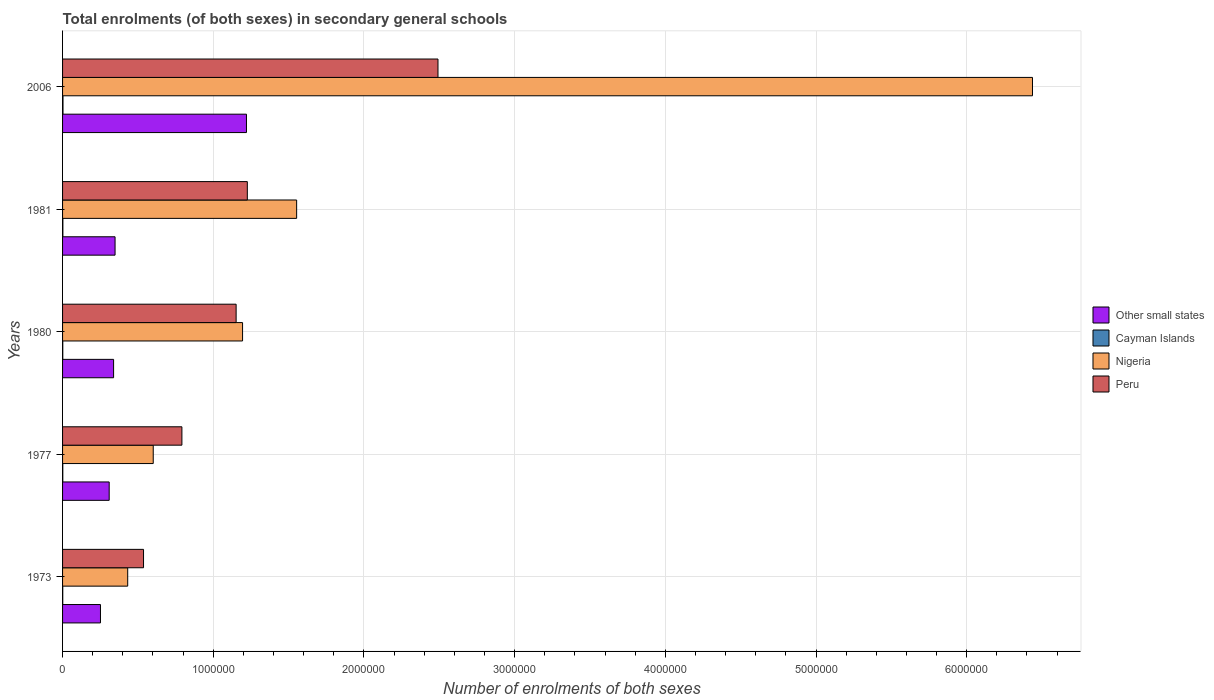How many different coloured bars are there?
Provide a succinct answer. 4. How many groups of bars are there?
Keep it short and to the point. 5. Are the number of bars per tick equal to the number of legend labels?
Your answer should be compact. Yes. Are the number of bars on each tick of the Y-axis equal?
Make the answer very short. Yes. What is the label of the 3rd group of bars from the top?
Offer a terse response. 1980. What is the number of enrolments in secondary schools in Nigeria in 2006?
Provide a short and direct response. 6.44e+06. Across all years, what is the maximum number of enrolments in secondary schools in Nigeria?
Offer a very short reply. 6.44e+06. Across all years, what is the minimum number of enrolments in secondary schools in Peru?
Your answer should be compact. 5.37e+05. In which year was the number of enrolments in secondary schools in Peru minimum?
Give a very brief answer. 1973. What is the total number of enrolments in secondary schools in Nigeria in the graph?
Provide a short and direct response. 1.02e+07. What is the difference between the number of enrolments in secondary schools in Peru in 1977 and that in 1980?
Your response must be concise. -3.60e+05. What is the difference between the number of enrolments in secondary schools in Cayman Islands in 1980 and the number of enrolments in secondary schools in Peru in 1977?
Offer a terse response. -7.90e+05. What is the average number of enrolments in secondary schools in Cayman Islands per year?
Offer a terse response. 1833. In the year 1973, what is the difference between the number of enrolments in secondary schools in Nigeria and number of enrolments in secondary schools in Other small states?
Give a very brief answer. 1.81e+05. What is the ratio of the number of enrolments in secondary schools in Cayman Islands in 1973 to that in 1980?
Your answer should be very brief. 0.82. Is the difference between the number of enrolments in secondary schools in Nigeria in 1977 and 1980 greater than the difference between the number of enrolments in secondary schools in Other small states in 1977 and 1980?
Provide a succinct answer. No. What is the difference between the highest and the second highest number of enrolments in secondary schools in Peru?
Offer a terse response. 1.27e+06. What is the difference between the highest and the lowest number of enrolments in secondary schools in Other small states?
Offer a terse response. 9.69e+05. Is the sum of the number of enrolments in secondary schools in Other small states in 1973 and 1977 greater than the maximum number of enrolments in secondary schools in Nigeria across all years?
Provide a succinct answer. No. What does the 4th bar from the top in 1973 represents?
Offer a very short reply. Other small states. What does the 3rd bar from the bottom in 2006 represents?
Offer a terse response. Nigeria. Is it the case that in every year, the sum of the number of enrolments in secondary schools in Nigeria and number of enrolments in secondary schools in Other small states is greater than the number of enrolments in secondary schools in Cayman Islands?
Ensure brevity in your answer.  Yes. Are all the bars in the graph horizontal?
Your answer should be very brief. Yes. How are the legend labels stacked?
Give a very brief answer. Vertical. What is the title of the graph?
Offer a very short reply. Total enrolments (of both sexes) in secondary general schools. Does "Tuvalu" appear as one of the legend labels in the graph?
Your response must be concise. No. What is the label or title of the X-axis?
Offer a terse response. Number of enrolments of both sexes. What is the label or title of the Y-axis?
Your response must be concise. Years. What is the Number of enrolments of both sexes of Other small states in 1973?
Your answer should be very brief. 2.52e+05. What is the Number of enrolments of both sexes of Cayman Islands in 1973?
Offer a very short reply. 1187. What is the Number of enrolments of both sexes of Nigeria in 1973?
Ensure brevity in your answer.  4.32e+05. What is the Number of enrolments of both sexes in Peru in 1973?
Provide a succinct answer. 5.37e+05. What is the Number of enrolments of both sexes in Other small states in 1977?
Your answer should be compact. 3.09e+05. What is the Number of enrolments of both sexes of Cayman Islands in 1977?
Your response must be concise. 1558. What is the Number of enrolments of both sexes of Nigeria in 1977?
Ensure brevity in your answer.  6.02e+05. What is the Number of enrolments of both sexes of Peru in 1977?
Your response must be concise. 7.92e+05. What is the Number of enrolments of both sexes in Other small states in 1980?
Provide a succinct answer. 3.39e+05. What is the Number of enrolments of both sexes in Cayman Islands in 1980?
Ensure brevity in your answer.  1446. What is the Number of enrolments of both sexes of Nigeria in 1980?
Make the answer very short. 1.19e+06. What is the Number of enrolments of both sexes in Peru in 1980?
Give a very brief answer. 1.15e+06. What is the Number of enrolments of both sexes of Other small states in 1981?
Your answer should be very brief. 3.48e+05. What is the Number of enrolments of both sexes in Cayman Islands in 1981?
Provide a short and direct response. 2075. What is the Number of enrolments of both sexes of Nigeria in 1981?
Offer a terse response. 1.55e+06. What is the Number of enrolments of both sexes of Peru in 1981?
Your response must be concise. 1.23e+06. What is the Number of enrolments of both sexes of Other small states in 2006?
Your response must be concise. 1.22e+06. What is the Number of enrolments of both sexes of Cayman Islands in 2006?
Provide a short and direct response. 2899. What is the Number of enrolments of both sexes of Nigeria in 2006?
Provide a short and direct response. 6.44e+06. What is the Number of enrolments of both sexes in Peru in 2006?
Ensure brevity in your answer.  2.49e+06. Across all years, what is the maximum Number of enrolments of both sexes of Other small states?
Your answer should be very brief. 1.22e+06. Across all years, what is the maximum Number of enrolments of both sexes of Cayman Islands?
Your response must be concise. 2899. Across all years, what is the maximum Number of enrolments of both sexes of Nigeria?
Provide a short and direct response. 6.44e+06. Across all years, what is the maximum Number of enrolments of both sexes of Peru?
Provide a short and direct response. 2.49e+06. Across all years, what is the minimum Number of enrolments of both sexes in Other small states?
Make the answer very short. 2.52e+05. Across all years, what is the minimum Number of enrolments of both sexes in Cayman Islands?
Offer a very short reply. 1187. Across all years, what is the minimum Number of enrolments of both sexes of Nigeria?
Offer a terse response. 4.32e+05. Across all years, what is the minimum Number of enrolments of both sexes of Peru?
Give a very brief answer. 5.37e+05. What is the total Number of enrolments of both sexes in Other small states in the graph?
Offer a very short reply. 2.47e+06. What is the total Number of enrolments of both sexes of Cayman Islands in the graph?
Make the answer very short. 9165. What is the total Number of enrolments of both sexes in Nigeria in the graph?
Your response must be concise. 1.02e+07. What is the total Number of enrolments of both sexes of Peru in the graph?
Give a very brief answer. 6.20e+06. What is the difference between the Number of enrolments of both sexes of Other small states in 1973 and that in 1977?
Provide a succinct answer. -5.79e+04. What is the difference between the Number of enrolments of both sexes in Cayman Islands in 1973 and that in 1977?
Make the answer very short. -371. What is the difference between the Number of enrolments of both sexes of Nigeria in 1973 and that in 1977?
Give a very brief answer. -1.69e+05. What is the difference between the Number of enrolments of both sexes of Peru in 1973 and that in 1977?
Make the answer very short. -2.55e+05. What is the difference between the Number of enrolments of both sexes of Other small states in 1973 and that in 1980?
Offer a terse response. -8.71e+04. What is the difference between the Number of enrolments of both sexes in Cayman Islands in 1973 and that in 1980?
Ensure brevity in your answer.  -259. What is the difference between the Number of enrolments of both sexes in Nigeria in 1973 and that in 1980?
Give a very brief answer. -7.62e+05. What is the difference between the Number of enrolments of both sexes of Peru in 1973 and that in 1980?
Provide a short and direct response. -6.14e+05. What is the difference between the Number of enrolments of both sexes in Other small states in 1973 and that in 1981?
Give a very brief answer. -9.68e+04. What is the difference between the Number of enrolments of both sexes in Cayman Islands in 1973 and that in 1981?
Your answer should be compact. -888. What is the difference between the Number of enrolments of both sexes of Nigeria in 1973 and that in 1981?
Your response must be concise. -1.12e+06. What is the difference between the Number of enrolments of both sexes in Peru in 1973 and that in 1981?
Offer a very short reply. -6.89e+05. What is the difference between the Number of enrolments of both sexes of Other small states in 1973 and that in 2006?
Your response must be concise. -9.69e+05. What is the difference between the Number of enrolments of both sexes of Cayman Islands in 1973 and that in 2006?
Provide a short and direct response. -1712. What is the difference between the Number of enrolments of both sexes of Nigeria in 1973 and that in 2006?
Provide a short and direct response. -6.00e+06. What is the difference between the Number of enrolments of both sexes of Peru in 1973 and that in 2006?
Make the answer very short. -1.95e+06. What is the difference between the Number of enrolments of both sexes of Other small states in 1977 and that in 1980?
Your answer should be very brief. -2.92e+04. What is the difference between the Number of enrolments of both sexes in Cayman Islands in 1977 and that in 1980?
Make the answer very short. 112. What is the difference between the Number of enrolments of both sexes in Nigeria in 1977 and that in 1980?
Keep it short and to the point. -5.93e+05. What is the difference between the Number of enrolments of both sexes of Peru in 1977 and that in 1980?
Ensure brevity in your answer.  -3.60e+05. What is the difference between the Number of enrolments of both sexes of Other small states in 1977 and that in 1981?
Provide a short and direct response. -3.89e+04. What is the difference between the Number of enrolments of both sexes in Cayman Islands in 1977 and that in 1981?
Offer a very short reply. -517. What is the difference between the Number of enrolments of both sexes of Nigeria in 1977 and that in 1981?
Offer a very short reply. -9.52e+05. What is the difference between the Number of enrolments of both sexes of Peru in 1977 and that in 1981?
Provide a short and direct response. -4.34e+05. What is the difference between the Number of enrolments of both sexes in Other small states in 1977 and that in 2006?
Your answer should be compact. -9.11e+05. What is the difference between the Number of enrolments of both sexes of Cayman Islands in 1977 and that in 2006?
Your answer should be very brief. -1341. What is the difference between the Number of enrolments of both sexes of Nigeria in 1977 and that in 2006?
Keep it short and to the point. -5.83e+06. What is the difference between the Number of enrolments of both sexes of Peru in 1977 and that in 2006?
Keep it short and to the point. -1.70e+06. What is the difference between the Number of enrolments of both sexes of Other small states in 1980 and that in 1981?
Your answer should be compact. -9750.81. What is the difference between the Number of enrolments of both sexes in Cayman Islands in 1980 and that in 1981?
Your answer should be compact. -629. What is the difference between the Number of enrolments of both sexes of Nigeria in 1980 and that in 1981?
Make the answer very short. -3.59e+05. What is the difference between the Number of enrolments of both sexes in Peru in 1980 and that in 1981?
Your answer should be compact. -7.44e+04. What is the difference between the Number of enrolments of both sexes in Other small states in 1980 and that in 2006?
Your answer should be very brief. -8.82e+05. What is the difference between the Number of enrolments of both sexes of Cayman Islands in 1980 and that in 2006?
Offer a very short reply. -1453. What is the difference between the Number of enrolments of both sexes of Nigeria in 1980 and that in 2006?
Offer a very short reply. -5.24e+06. What is the difference between the Number of enrolments of both sexes in Peru in 1980 and that in 2006?
Provide a short and direct response. -1.34e+06. What is the difference between the Number of enrolments of both sexes in Other small states in 1981 and that in 2006?
Give a very brief answer. -8.72e+05. What is the difference between the Number of enrolments of both sexes in Cayman Islands in 1981 and that in 2006?
Your response must be concise. -824. What is the difference between the Number of enrolments of both sexes in Nigeria in 1981 and that in 2006?
Your response must be concise. -4.88e+06. What is the difference between the Number of enrolments of both sexes of Peru in 1981 and that in 2006?
Your answer should be compact. -1.27e+06. What is the difference between the Number of enrolments of both sexes in Other small states in 1973 and the Number of enrolments of both sexes in Cayman Islands in 1977?
Offer a terse response. 2.50e+05. What is the difference between the Number of enrolments of both sexes in Other small states in 1973 and the Number of enrolments of both sexes in Nigeria in 1977?
Offer a terse response. -3.50e+05. What is the difference between the Number of enrolments of both sexes in Other small states in 1973 and the Number of enrolments of both sexes in Peru in 1977?
Provide a short and direct response. -5.40e+05. What is the difference between the Number of enrolments of both sexes in Cayman Islands in 1973 and the Number of enrolments of both sexes in Nigeria in 1977?
Your response must be concise. -6.00e+05. What is the difference between the Number of enrolments of both sexes of Cayman Islands in 1973 and the Number of enrolments of both sexes of Peru in 1977?
Provide a succinct answer. -7.91e+05. What is the difference between the Number of enrolments of both sexes of Nigeria in 1973 and the Number of enrolments of both sexes of Peru in 1977?
Give a very brief answer. -3.60e+05. What is the difference between the Number of enrolments of both sexes of Other small states in 1973 and the Number of enrolments of both sexes of Cayman Islands in 1980?
Ensure brevity in your answer.  2.50e+05. What is the difference between the Number of enrolments of both sexes in Other small states in 1973 and the Number of enrolments of both sexes in Nigeria in 1980?
Provide a short and direct response. -9.43e+05. What is the difference between the Number of enrolments of both sexes of Other small states in 1973 and the Number of enrolments of both sexes of Peru in 1980?
Give a very brief answer. -9.00e+05. What is the difference between the Number of enrolments of both sexes in Cayman Islands in 1973 and the Number of enrolments of both sexes in Nigeria in 1980?
Make the answer very short. -1.19e+06. What is the difference between the Number of enrolments of both sexes of Cayman Islands in 1973 and the Number of enrolments of both sexes of Peru in 1980?
Offer a very short reply. -1.15e+06. What is the difference between the Number of enrolments of both sexes in Nigeria in 1973 and the Number of enrolments of both sexes in Peru in 1980?
Your answer should be very brief. -7.19e+05. What is the difference between the Number of enrolments of both sexes in Other small states in 1973 and the Number of enrolments of both sexes in Cayman Islands in 1981?
Your answer should be very brief. 2.49e+05. What is the difference between the Number of enrolments of both sexes in Other small states in 1973 and the Number of enrolments of both sexes in Nigeria in 1981?
Provide a succinct answer. -1.30e+06. What is the difference between the Number of enrolments of both sexes of Other small states in 1973 and the Number of enrolments of both sexes of Peru in 1981?
Give a very brief answer. -9.75e+05. What is the difference between the Number of enrolments of both sexes of Cayman Islands in 1973 and the Number of enrolments of both sexes of Nigeria in 1981?
Your response must be concise. -1.55e+06. What is the difference between the Number of enrolments of both sexes of Cayman Islands in 1973 and the Number of enrolments of both sexes of Peru in 1981?
Provide a short and direct response. -1.22e+06. What is the difference between the Number of enrolments of both sexes of Nigeria in 1973 and the Number of enrolments of both sexes of Peru in 1981?
Provide a short and direct response. -7.94e+05. What is the difference between the Number of enrolments of both sexes in Other small states in 1973 and the Number of enrolments of both sexes in Cayman Islands in 2006?
Provide a succinct answer. 2.49e+05. What is the difference between the Number of enrolments of both sexes of Other small states in 1973 and the Number of enrolments of both sexes of Nigeria in 2006?
Ensure brevity in your answer.  -6.18e+06. What is the difference between the Number of enrolments of both sexes of Other small states in 1973 and the Number of enrolments of both sexes of Peru in 2006?
Keep it short and to the point. -2.24e+06. What is the difference between the Number of enrolments of both sexes in Cayman Islands in 1973 and the Number of enrolments of both sexes in Nigeria in 2006?
Your answer should be compact. -6.44e+06. What is the difference between the Number of enrolments of both sexes of Cayman Islands in 1973 and the Number of enrolments of both sexes of Peru in 2006?
Provide a short and direct response. -2.49e+06. What is the difference between the Number of enrolments of both sexes of Nigeria in 1973 and the Number of enrolments of both sexes of Peru in 2006?
Give a very brief answer. -2.06e+06. What is the difference between the Number of enrolments of both sexes of Other small states in 1977 and the Number of enrolments of both sexes of Cayman Islands in 1980?
Your answer should be very brief. 3.08e+05. What is the difference between the Number of enrolments of both sexes of Other small states in 1977 and the Number of enrolments of both sexes of Nigeria in 1980?
Provide a succinct answer. -8.85e+05. What is the difference between the Number of enrolments of both sexes in Other small states in 1977 and the Number of enrolments of both sexes in Peru in 1980?
Your answer should be compact. -8.42e+05. What is the difference between the Number of enrolments of both sexes of Cayman Islands in 1977 and the Number of enrolments of both sexes of Nigeria in 1980?
Offer a terse response. -1.19e+06. What is the difference between the Number of enrolments of both sexes of Cayman Islands in 1977 and the Number of enrolments of both sexes of Peru in 1980?
Your response must be concise. -1.15e+06. What is the difference between the Number of enrolments of both sexes in Nigeria in 1977 and the Number of enrolments of both sexes in Peru in 1980?
Your answer should be compact. -5.50e+05. What is the difference between the Number of enrolments of both sexes in Other small states in 1977 and the Number of enrolments of both sexes in Cayman Islands in 1981?
Ensure brevity in your answer.  3.07e+05. What is the difference between the Number of enrolments of both sexes in Other small states in 1977 and the Number of enrolments of both sexes in Nigeria in 1981?
Ensure brevity in your answer.  -1.24e+06. What is the difference between the Number of enrolments of both sexes in Other small states in 1977 and the Number of enrolments of both sexes in Peru in 1981?
Your answer should be compact. -9.17e+05. What is the difference between the Number of enrolments of both sexes in Cayman Islands in 1977 and the Number of enrolments of both sexes in Nigeria in 1981?
Keep it short and to the point. -1.55e+06. What is the difference between the Number of enrolments of both sexes of Cayman Islands in 1977 and the Number of enrolments of both sexes of Peru in 1981?
Make the answer very short. -1.22e+06. What is the difference between the Number of enrolments of both sexes in Nigeria in 1977 and the Number of enrolments of both sexes in Peru in 1981?
Your response must be concise. -6.24e+05. What is the difference between the Number of enrolments of both sexes in Other small states in 1977 and the Number of enrolments of both sexes in Cayman Islands in 2006?
Keep it short and to the point. 3.07e+05. What is the difference between the Number of enrolments of both sexes in Other small states in 1977 and the Number of enrolments of both sexes in Nigeria in 2006?
Offer a very short reply. -6.13e+06. What is the difference between the Number of enrolments of both sexes of Other small states in 1977 and the Number of enrolments of both sexes of Peru in 2006?
Give a very brief answer. -2.18e+06. What is the difference between the Number of enrolments of both sexes in Cayman Islands in 1977 and the Number of enrolments of both sexes in Nigeria in 2006?
Offer a terse response. -6.43e+06. What is the difference between the Number of enrolments of both sexes of Cayman Islands in 1977 and the Number of enrolments of both sexes of Peru in 2006?
Provide a succinct answer. -2.49e+06. What is the difference between the Number of enrolments of both sexes in Nigeria in 1977 and the Number of enrolments of both sexes in Peru in 2006?
Give a very brief answer. -1.89e+06. What is the difference between the Number of enrolments of both sexes of Other small states in 1980 and the Number of enrolments of both sexes of Cayman Islands in 1981?
Your response must be concise. 3.37e+05. What is the difference between the Number of enrolments of both sexes of Other small states in 1980 and the Number of enrolments of both sexes of Nigeria in 1981?
Your response must be concise. -1.21e+06. What is the difference between the Number of enrolments of both sexes in Other small states in 1980 and the Number of enrolments of both sexes in Peru in 1981?
Provide a short and direct response. -8.88e+05. What is the difference between the Number of enrolments of both sexes of Cayman Islands in 1980 and the Number of enrolments of both sexes of Nigeria in 1981?
Offer a very short reply. -1.55e+06. What is the difference between the Number of enrolments of both sexes in Cayman Islands in 1980 and the Number of enrolments of both sexes in Peru in 1981?
Your answer should be very brief. -1.22e+06. What is the difference between the Number of enrolments of both sexes of Nigeria in 1980 and the Number of enrolments of both sexes of Peru in 1981?
Make the answer very short. -3.17e+04. What is the difference between the Number of enrolments of both sexes in Other small states in 1980 and the Number of enrolments of both sexes in Cayman Islands in 2006?
Provide a succinct answer. 3.36e+05. What is the difference between the Number of enrolments of both sexes of Other small states in 1980 and the Number of enrolments of both sexes of Nigeria in 2006?
Your answer should be very brief. -6.10e+06. What is the difference between the Number of enrolments of both sexes of Other small states in 1980 and the Number of enrolments of both sexes of Peru in 2006?
Your answer should be very brief. -2.15e+06. What is the difference between the Number of enrolments of both sexes in Cayman Islands in 1980 and the Number of enrolments of both sexes in Nigeria in 2006?
Provide a short and direct response. -6.44e+06. What is the difference between the Number of enrolments of both sexes of Cayman Islands in 1980 and the Number of enrolments of both sexes of Peru in 2006?
Keep it short and to the point. -2.49e+06. What is the difference between the Number of enrolments of both sexes in Nigeria in 1980 and the Number of enrolments of both sexes in Peru in 2006?
Give a very brief answer. -1.30e+06. What is the difference between the Number of enrolments of both sexes in Other small states in 1981 and the Number of enrolments of both sexes in Cayman Islands in 2006?
Give a very brief answer. 3.45e+05. What is the difference between the Number of enrolments of both sexes of Other small states in 1981 and the Number of enrolments of both sexes of Nigeria in 2006?
Provide a succinct answer. -6.09e+06. What is the difference between the Number of enrolments of both sexes in Other small states in 1981 and the Number of enrolments of both sexes in Peru in 2006?
Ensure brevity in your answer.  -2.14e+06. What is the difference between the Number of enrolments of both sexes of Cayman Islands in 1981 and the Number of enrolments of both sexes of Nigeria in 2006?
Ensure brevity in your answer.  -6.43e+06. What is the difference between the Number of enrolments of both sexes in Cayman Islands in 1981 and the Number of enrolments of both sexes in Peru in 2006?
Your response must be concise. -2.49e+06. What is the difference between the Number of enrolments of both sexes in Nigeria in 1981 and the Number of enrolments of both sexes in Peru in 2006?
Keep it short and to the point. -9.38e+05. What is the average Number of enrolments of both sexes of Other small states per year?
Give a very brief answer. 4.94e+05. What is the average Number of enrolments of both sexes in Cayman Islands per year?
Provide a succinct answer. 1833. What is the average Number of enrolments of both sexes of Nigeria per year?
Offer a terse response. 2.04e+06. What is the average Number of enrolments of both sexes in Peru per year?
Offer a terse response. 1.24e+06. In the year 1973, what is the difference between the Number of enrolments of both sexes of Other small states and Number of enrolments of both sexes of Cayman Islands?
Provide a succinct answer. 2.50e+05. In the year 1973, what is the difference between the Number of enrolments of both sexes of Other small states and Number of enrolments of both sexes of Nigeria?
Your answer should be compact. -1.81e+05. In the year 1973, what is the difference between the Number of enrolments of both sexes in Other small states and Number of enrolments of both sexes in Peru?
Your answer should be very brief. -2.86e+05. In the year 1973, what is the difference between the Number of enrolments of both sexes of Cayman Islands and Number of enrolments of both sexes of Nigeria?
Keep it short and to the point. -4.31e+05. In the year 1973, what is the difference between the Number of enrolments of both sexes in Cayman Islands and Number of enrolments of both sexes in Peru?
Ensure brevity in your answer.  -5.36e+05. In the year 1973, what is the difference between the Number of enrolments of both sexes in Nigeria and Number of enrolments of both sexes in Peru?
Keep it short and to the point. -1.05e+05. In the year 1977, what is the difference between the Number of enrolments of both sexes of Other small states and Number of enrolments of both sexes of Cayman Islands?
Keep it short and to the point. 3.08e+05. In the year 1977, what is the difference between the Number of enrolments of both sexes of Other small states and Number of enrolments of both sexes of Nigeria?
Make the answer very short. -2.92e+05. In the year 1977, what is the difference between the Number of enrolments of both sexes of Other small states and Number of enrolments of both sexes of Peru?
Offer a very short reply. -4.83e+05. In the year 1977, what is the difference between the Number of enrolments of both sexes in Cayman Islands and Number of enrolments of both sexes in Nigeria?
Keep it short and to the point. -6.00e+05. In the year 1977, what is the difference between the Number of enrolments of both sexes in Cayman Islands and Number of enrolments of both sexes in Peru?
Offer a terse response. -7.90e+05. In the year 1977, what is the difference between the Number of enrolments of both sexes of Nigeria and Number of enrolments of both sexes of Peru?
Keep it short and to the point. -1.90e+05. In the year 1980, what is the difference between the Number of enrolments of both sexes of Other small states and Number of enrolments of both sexes of Cayman Islands?
Your response must be concise. 3.37e+05. In the year 1980, what is the difference between the Number of enrolments of both sexes in Other small states and Number of enrolments of both sexes in Nigeria?
Your answer should be very brief. -8.56e+05. In the year 1980, what is the difference between the Number of enrolments of both sexes of Other small states and Number of enrolments of both sexes of Peru?
Offer a terse response. -8.13e+05. In the year 1980, what is the difference between the Number of enrolments of both sexes of Cayman Islands and Number of enrolments of both sexes of Nigeria?
Provide a succinct answer. -1.19e+06. In the year 1980, what is the difference between the Number of enrolments of both sexes in Cayman Islands and Number of enrolments of both sexes in Peru?
Offer a very short reply. -1.15e+06. In the year 1980, what is the difference between the Number of enrolments of both sexes in Nigeria and Number of enrolments of both sexes in Peru?
Offer a terse response. 4.27e+04. In the year 1981, what is the difference between the Number of enrolments of both sexes in Other small states and Number of enrolments of both sexes in Cayman Islands?
Make the answer very short. 3.46e+05. In the year 1981, what is the difference between the Number of enrolments of both sexes of Other small states and Number of enrolments of both sexes of Nigeria?
Ensure brevity in your answer.  -1.20e+06. In the year 1981, what is the difference between the Number of enrolments of both sexes in Other small states and Number of enrolments of both sexes in Peru?
Make the answer very short. -8.78e+05. In the year 1981, what is the difference between the Number of enrolments of both sexes of Cayman Islands and Number of enrolments of both sexes of Nigeria?
Ensure brevity in your answer.  -1.55e+06. In the year 1981, what is the difference between the Number of enrolments of both sexes in Cayman Islands and Number of enrolments of both sexes in Peru?
Ensure brevity in your answer.  -1.22e+06. In the year 1981, what is the difference between the Number of enrolments of both sexes in Nigeria and Number of enrolments of both sexes in Peru?
Your response must be concise. 3.27e+05. In the year 2006, what is the difference between the Number of enrolments of both sexes of Other small states and Number of enrolments of both sexes of Cayman Islands?
Your answer should be compact. 1.22e+06. In the year 2006, what is the difference between the Number of enrolments of both sexes of Other small states and Number of enrolments of both sexes of Nigeria?
Provide a short and direct response. -5.22e+06. In the year 2006, what is the difference between the Number of enrolments of both sexes of Other small states and Number of enrolments of both sexes of Peru?
Give a very brief answer. -1.27e+06. In the year 2006, what is the difference between the Number of enrolments of both sexes of Cayman Islands and Number of enrolments of both sexes of Nigeria?
Offer a very short reply. -6.43e+06. In the year 2006, what is the difference between the Number of enrolments of both sexes in Cayman Islands and Number of enrolments of both sexes in Peru?
Your answer should be compact. -2.49e+06. In the year 2006, what is the difference between the Number of enrolments of both sexes of Nigeria and Number of enrolments of both sexes of Peru?
Your answer should be compact. 3.95e+06. What is the ratio of the Number of enrolments of both sexes in Other small states in 1973 to that in 1977?
Your answer should be very brief. 0.81. What is the ratio of the Number of enrolments of both sexes in Cayman Islands in 1973 to that in 1977?
Offer a terse response. 0.76. What is the ratio of the Number of enrolments of both sexes in Nigeria in 1973 to that in 1977?
Ensure brevity in your answer.  0.72. What is the ratio of the Number of enrolments of both sexes in Peru in 1973 to that in 1977?
Make the answer very short. 0.68. What is the ratio of the Number of enrolments of both sexes of Other small states in 1973 to that in 1980?
Provide a short and direct response. 0.74. What is the ratio of the Number of enrolments of both sexes of Cayman Islands in 1973 to that in 1980?
Provide a short and direct response. 0.82. What is the ratio of the Number of enrolments of both sexes in Nigeria in 1973 to that in 1980?
Offer a terse response. 0.36. What is the ratio of the Number of enrolments of both sexes of Peru in 1973 to that in 1980?
Your response must be concise. 0.47. What is the ratio of the Number of enrolments of both sexes of Other small states in 1973 to that in 1981?
Offer a terse response. 0.72. What is the ratio of the Number of enrolments of both sexes of Cayman Islands in 1973 to that in 1981?
Offer a terse response. 0.57. What is the ratio of the Number of enrolments of both sexes of Nigeria in 1973 to that in 1981?
Your response must be concise. 0.28. What is the ratio of the Number of enrolments of both sexes in Peru in 1973 to that in 1981?
Your answer should be very brief. 0.44. What is the ratio of the Number of enrolments of both sexes of Other small states in 1973 to that in 2006?
Make the answer very short. 0.21. What is the ratio of the Number of enrolments of both sexes of Cayman Islands in 1973 to that in 2006?
Make the answer very short. 0.41. What is the ratio of the Number of enrolments of both sexes of Nigeria in 1973 to that in 2006?
Offer a terse response. 0.07. What is the ratio of the Number of enrolments of both sexes of Peru in 1973 to that in 2006?
Keep it short and to the point. 0.22. What is the ratio of the Number of enrolments of both sexes in Other small states in 1977 to that in 1980?
Your answer should be compact. 0.91. What is the ratio of the Number of enrolments of both sexes of Cayman Islands in 1977 to that in 1980?
Your answer should be compact. 1.08. What is the ratio of the Number of enrolments of both sexes in Nigeria in 1977 to that in 1980?
Provide a short and direct response. 0.5. What is the ratio of the Number of enrolments of both sexes of Peru in 1977 to that in 1980?
Offer a terse response. 0.69. What is the ratio of the Number of enrolments of both sexes of Other small states in 1977 to that in 1981?
Offer a terse response. 0.89. What is the ratio of the Number of enrolments of both sexes of Cayman Islands in 1977 to that in 1981?
Provide a short and direct response. 0.75. What is the ratio of the Number of enrolments of both sexes of Nigeria in 1977 to that in 1981?
Keep it short and to the point. 0.39. What is the ratio of the Number of enrolments of both sexes of Peru in 1977 to that in 1981?
Offer a very short reply. 0.65. What is the ratio of the Number of enrolments of both sexes of Other small states in 1977 to that in 2006?
Your answer should be compact. 0.25. What is the ratio of the Number of enrolments of both sexes in Cayman Islands in 1977 to that in 2006?
Provide a succinct answer. 0.54. What is the ratio of the Number of enrolments of both sexes in Nigeria in 1977 to that in 2006?
Make the answer very short. 0.09. What is the ratio of the Number of enrolments of both sexes in Peru in 1977 to that in 2006?
Your answer should be compact. 0.32. What is the ratio of the Number of enrolments of both sexes of Other small states in 1980 to that in 1981?
Your answer should be compact. 0.97. What is the ratio of the Number of enrolments of both sexes in Cayman Islands in 1980 to that in 1981?
Provide a short and direct response. 0.7. What is the ratio of the Number of enrolments of both sexes in Nigeria in 1980 to that in 1981?
Your response must be concise. 0.77. What is the ratio of the Number of enrolments of both sexes in Peru in 1980 to that in 1981?
Offer a terse response. 0.94. What is the ratio of the Number of enrolments of both sexes of Other small states in 1980 to that in 2006?
Provide a succinct answer. 0.28. What is the ratio of the Number of enrolments of both sexes of Cayman Islands in 1980 to that in 2006?
Offer a very short reply. 0.5. What is the ratio of the Number of enrolments of both sexes in Nigeria in 1980 to that in 2006?
Give a very brief answer. 0.19. What is the ratio of the Number of enrolments of both sexes in Peru in 1980 to that in 2006?
Provide a succinct answer. 0.46. What is the ratio of the Number of enrolments of both sexes in Other small states in 1981 to that in 2006?
Make the answer very short. 0.29. What is the ratio of the Number of enrolments of both sexes of Cayman Islands in 1981 to that in 2006?
Your answer should be very brief. 0.72. What is the ratio of the Number of enrolments of both sexes in Nigeria in 1981 to that in 2006?
Your answer should be very brief. 0.24. What is the ratio of the Number of enrolments of both sexes of Peru in 1981 to that in 2006?
Give a very brief answer. 0.49. What is the difference between the highest and the second highest Number of enrolments of both sexes of Other small states?
Offer a terse response. 8.72e+05. What is the difference between the highest and the second highest Number of enrolments of both sexes of Cayman Islands?
Offer a terse response. 824. What is the difference between the highest and the second highest Number of enrolments of both sexes in Nigeria?
Make the answer very short. 4.88e+06. What is the difference between the highest and the second highest Number of enrolments of both sexes in Peru?
Provide a succinct answer. 1.27e+06. What is the difference between the highest and the lowest Number of enrolments of both sexes of Other small states?
Your response must be concise. 9.69e+05. What is the difference between the highest and the lowest Number of enrolments of both sexes of Cayman Islands?
Ensure brevity in your answer.  1712. What is the difference between the highest and the lowest Number of enrolments of both sexes in Nigeria?
Make the answer very short. 6.00e+06. What is the difference between the highest and the lowest Number of enrolments of both sexes of Peru?
Your answer should be compact. 1.95e+06. 